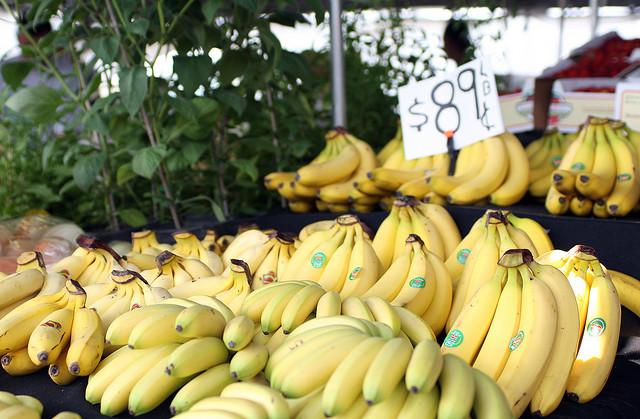How much is a pound of bananas?
Write a very short answer. 89. What type of fruit is pictured?
Concise answer only. Banana. Is this too many bananas?
Keep it brief. No. What does the sign say?
Write a very short answer. $.89 lb. 